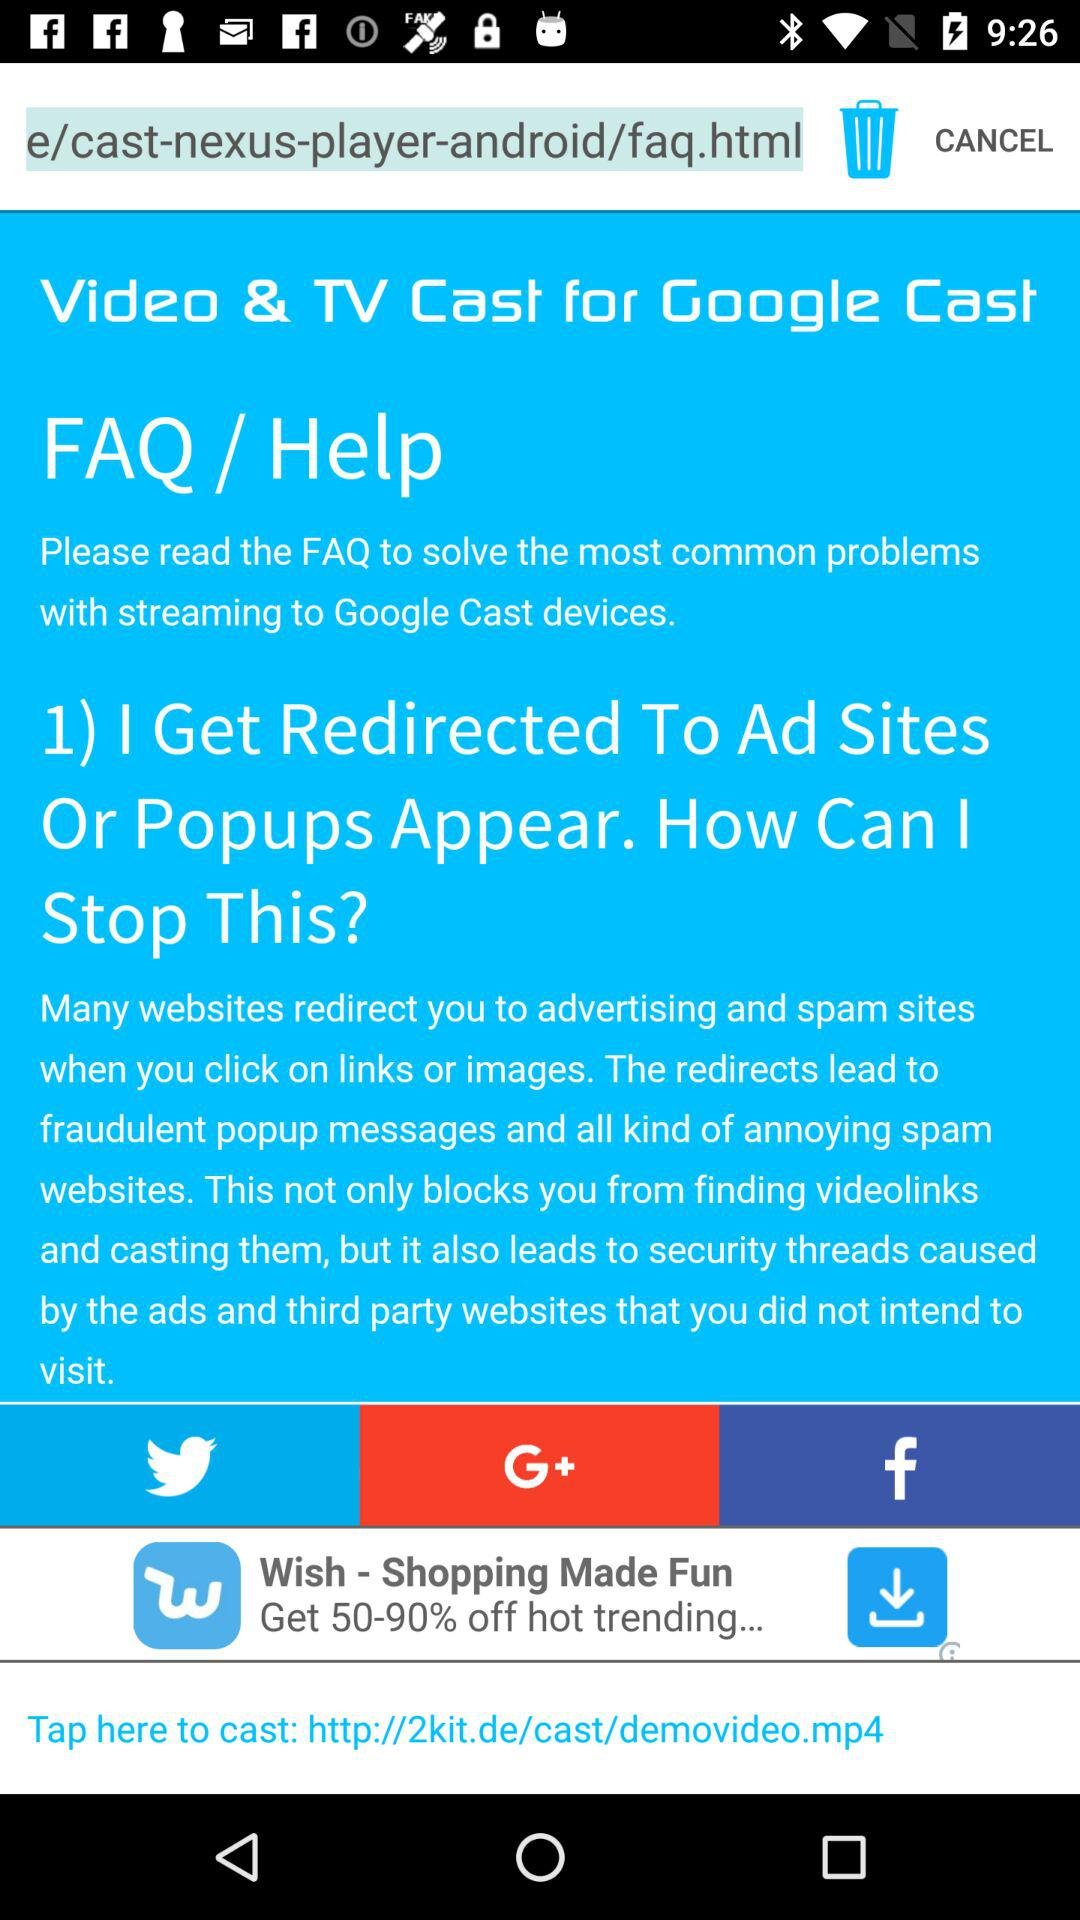What accounts can I use to sign up? You can sign up with "Twitter", "Google+" and "Facebook". 